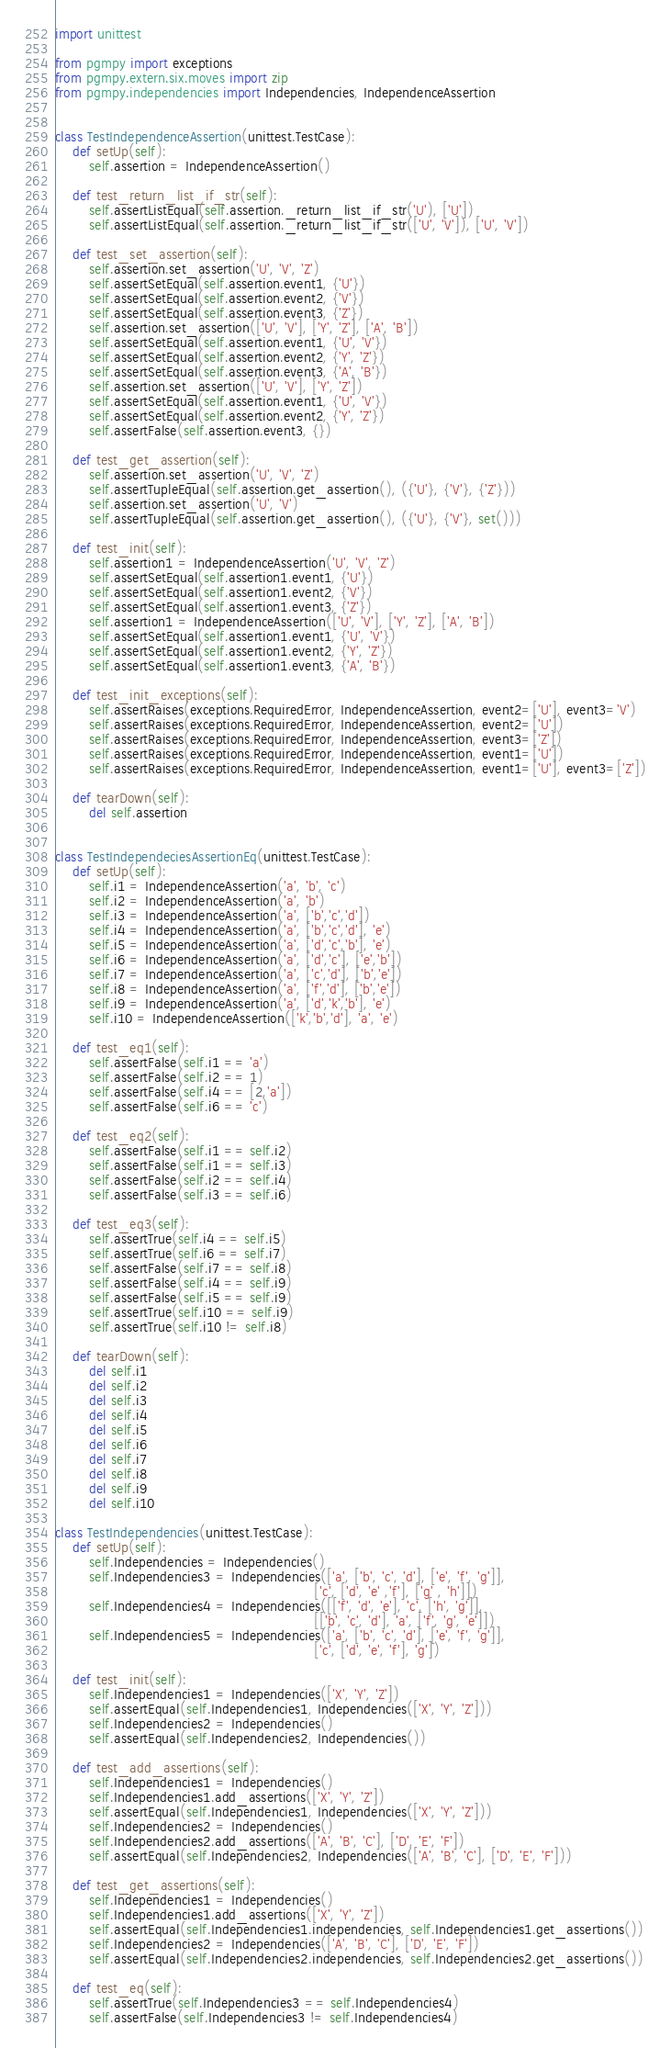<code> <loc_0><loc_0><loc_500><loc_500><_Python_>import unittest

from pgmpy import exceptions
from pgmpy.extern.six.moves import zip
from pgmpy.independencies import Independencies, IndependenceAssertion


class TestIndependenceAssertion(unittest.TestCase):
    def setUp(self):
        self.assertion = IndependenceAssertion()

    def test_return_list_if_str(self):
        self.assertListEqual(self.assertion._return_list_if_str('U'), ['U'])
        self.assertListEqual(self.assertion._return_list_if_str(['U', 'V']), ['U', 'V'])

    def test_set_assertion(self):
        self.assertion.set_assertion('U', 'V', 'Z')
        self.assertSetEqual(self.assertion.event1, {'U'})
        self.assertSetEqual(self.assertion.event2, {'V'})
        self.assertSetEqual(self.assertion.event3, {'Z'})
        self.assertion.set_assertion(['U', 'V'], ['Y', 'Z'], ['A', 'B'])
        self.assertSetEqual(self.assertion.event1, {'U', 'V'})
        self.assertSetEqual(self.assertion.event2, {'Y', 'Z'})
        self.assertSetEqual(self.assertion.event3, {'A', 'B'})
        self.assertion.set_assertion(['U', 'V'], ['Y', 'Z'])
        self.assertSetEqual(self.assertion.event1, {'U', 'V'})
        self.assertSetEqual(self.assertion.event2, {'Y', 'Z'})
        self.assertFalse(self.assertion.event3, {})

    def test_get_assertion(self):
        self.assertion.set_assertion('U', 'V', 'Z')
        self.assertTupleEqual(self.assertion.get_assertion(), ({'U'}, {'V'}, {'Z'}))
        self.assertion.set_assertion('U', 'V')
        self.assertTupleEqual(self.assertion.get_assertion(), ({'U'}, {'V'}, set()))

    def test_init(self):
        self.assertion1 = IndependenceAssertion('U', 'V', 'Z')
        self.assertSetEqual(self.assertion1.event1, {'U'})
        self.assertSetEqual(self.assertion1.event2, {'V'})
        self.assertSetEqual(self.assertion1.event3, {'Z'})
        self.assertion1 = IndependenceAssertion(['U', 'V'], ['Y', 'Z'], ['A', 'B'])
        self.assertSetEqual(self.assertion1.event1, {'U', 'V'})
        self.assertSetEqual(self.assertion1.event2, {'Y', 'Z'})
        self.assertSetEqual(self.assertion1.event3, {'A', 'B'})

    def test_init_exceptions(self):
        self.assertRaises(exceptions.RequiredError, IndependenceAssertion, event2=['U'], event3='V')
        self.assertRaises(exceptions.RequiredError, IndependenceAssertion, event2=['U'])
        self.assertRaises(exceptions.RequiredError, IndependenceAssertion, event3=['Z'])
        self.assertRaises(exceptions.RequiredError, IndependenceAssertion, event1=['U'])
        self.assertRaises(exceptions.RequiredError, IndependenceAssertion, event1=['U'], event3=['Z'])

    def tearDown(self):
        del self.assertion


class TestIndependeciesAssertionEq(unittest.TestCase):
    def setUp(self):
        self.i1 = IndependenceAssertion('a', 'b', 'c')
        self.i2 = IndependenceAssertion('a', 'b')
        self.i3 = IndependenceAssertion('a', ['b','c','d'])
        self.i4 = IndependenceAssertion('a', ['b','c','d'], 'e')
        self.i5 = IndependenceAssertion('a', ['d','c','b'], 'e')
        self.i6 = IndependenceAssertion('a', ['d','c'], ['e','b'])
        self.i7 = IndependenceAssertion('a', ['c','d'], ['b','e'])
        self.i8 = IndependenceAssertion('a', ['f','d'], ['b','e'])
        self.i9 = IndependenceAssertion('a', ['d','k','b'], 'e')
        self.i10 = IndependenceAssertion(['k','b','d'], 'a', 'e')

    def test_eq1(self):
        self.assertFalse(self.i1 == 'a')
        self.assertFalse(self.i2 == 1)
        self.assertFalse(self.i4 == [2,'a'])
        self.assertFalse(self.i6 == 'c')

    def test_eq2(self):
        self.assertFalse(self.i1 == self.i2)
        self.assertFalse(self.i1 == self.i3)
        self.assertFalse(self.i2 == self.i4)
        self.assertFalse(self.i3 == self.i6)

    def test_eq3(self):
        self.assertTrue(self.i4 == self.i5)
        self.assertTrue(self.i6 == self.i7)
        self.assertFalse(self.i7 == self.i8)
        self.assertFalse(self.i4 == self.i9)
        self.assertFalse(self.i5 == self.i9)
        self.assertTrue(self.i10 == self.i9)
        self.assertTrue(self.i10 != self.i8)

    def tearDown(self):
        del self.i1
        del self.i2
        del self.i3
        del self.i4
        del self.i5
        del self.i6
        del self.i7
        del self.i8
        del self.i9
        del self.i10

class TestIndependencies(unittest.TestCase):
    def setUp(self):
        self.Independencies = Independencies()
        self.Independencies3 = Independencies(['a', ['b', 'c', 'd'], ['e', 'f', 'g']],
                                                             ['c', ['d', 'e' ,'f'], ['g' , 'h']])
        self.Independencies4 = Independencies([['f', 'd', 'e'], 'c', ['h', 'g']],
                                                             [['b', 'c', 'd'], 'a', ['f', 'g', 'e']])
        self.Independencies5 = Independencies(['a', ['b', 'c', 'd'], ['e', 'f', 'g']],
                                                             ['c', ['d', 'e', 'f'], 'g'])

    def test_init(self):
        self.Independencies1 = Independencies(['X', 'Y', 'Z'])
        self.assertEqual(self.Independencies1, Independencies(['X', 'Y', 'Z']))
        self.Independencies2 = Independencies()
        self.assertEqual(self.Independencies2, Independencies())

    def test_add_assertions(self):
        self.Independencies1 = Independencies()
        self.Independencies1.add_assertions(['X', 'Y', 'Z'])
        self.assertEqual(self.Independencies1, Independencies(['X', 'Y', 'Z']))
        self.Independencies2 = Independencies()
        self.Independencies2.add_assertions(['A', 'B', 'C'], ['D', 'E', 'F'])
        self.assertEqual(self.Independencies2, Independencies(['A', 'B', 'C'], ['D', 'E', 'F']))

    def test_get_assertions(self):
        self.Independencies1 = Independencies()
        self.Independencies1.add_assertions(['X', 'Y', 'Z'])
        self.assertEqual(self.Independencies1.independencies, self.Independencies1.get_assertions())
        self.Independencies2 = Independencies(['A', 'B', 'C'], ['D', 'E', 'F'])
        self.assertEqual(self.Independencies2.independencies, self.Independencies2.get_assertions())

    def test_eq(self):
        self.assertTrue(self.Independencies3 == self.Independencies4)
        self.assertFalse(self.Independencies3 != self.Independencies4)</code> 